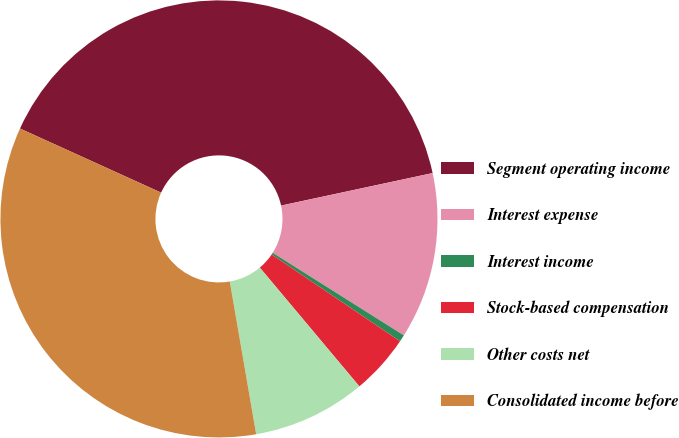Convert chart. <chart><loc_0><loc_0><loc_500><loc_500><pie_chart><fcel>Segment operating income<fcel>Interest expense<fcel>Interest income<fcel>Stock-based compensation<fcel>Other costs net<fcel>Consolidated income before<nl><fcel>39.85%<fcel>12.31%<fcel>0.51%<fcel>4.44%<fcel>8.38%<fcel>34.51%<nl></chart> 